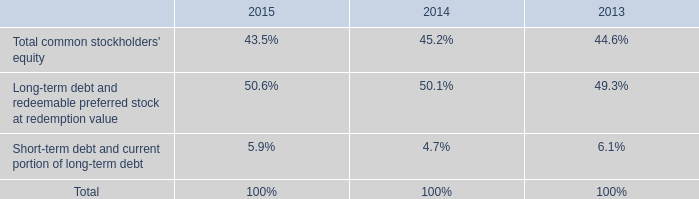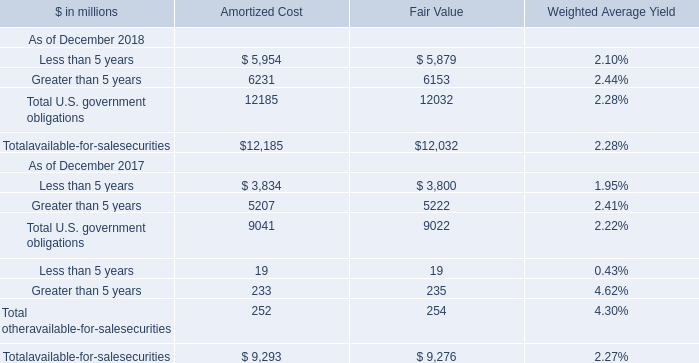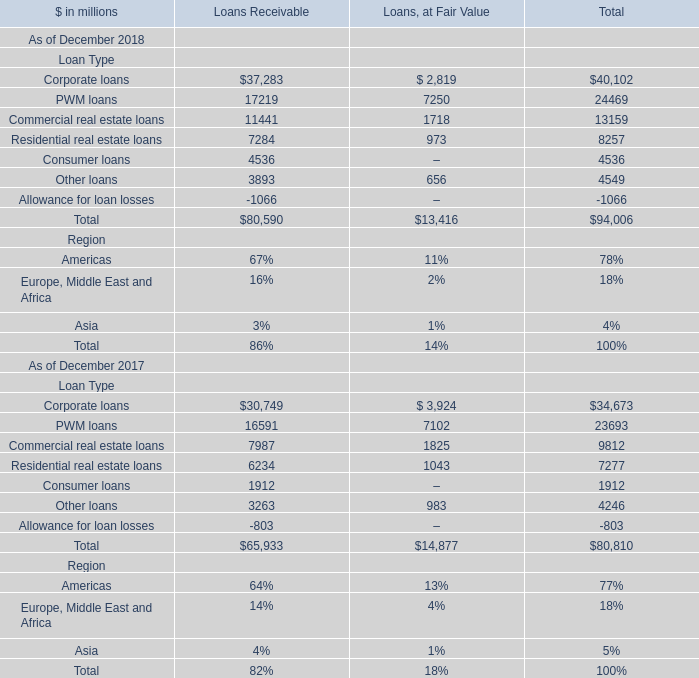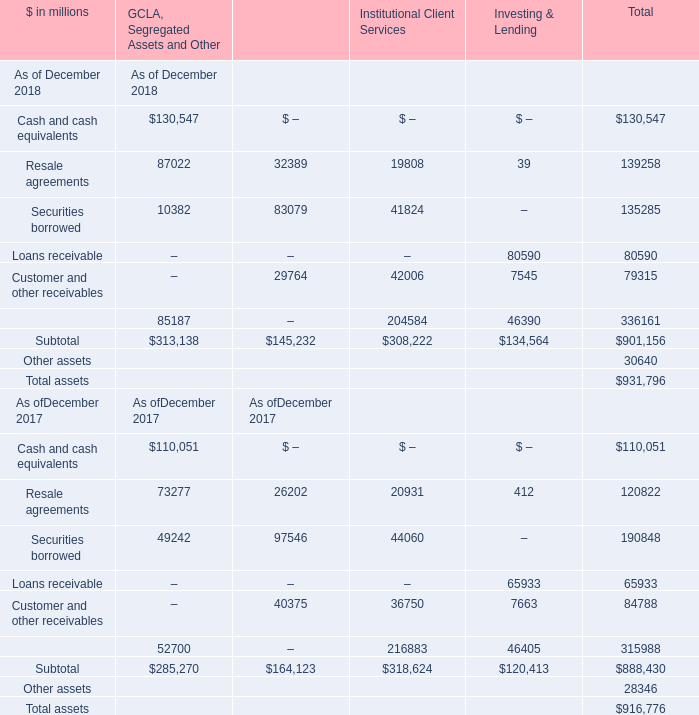Which year is Loans receivable the most for Total? 
Answer: 2018. 